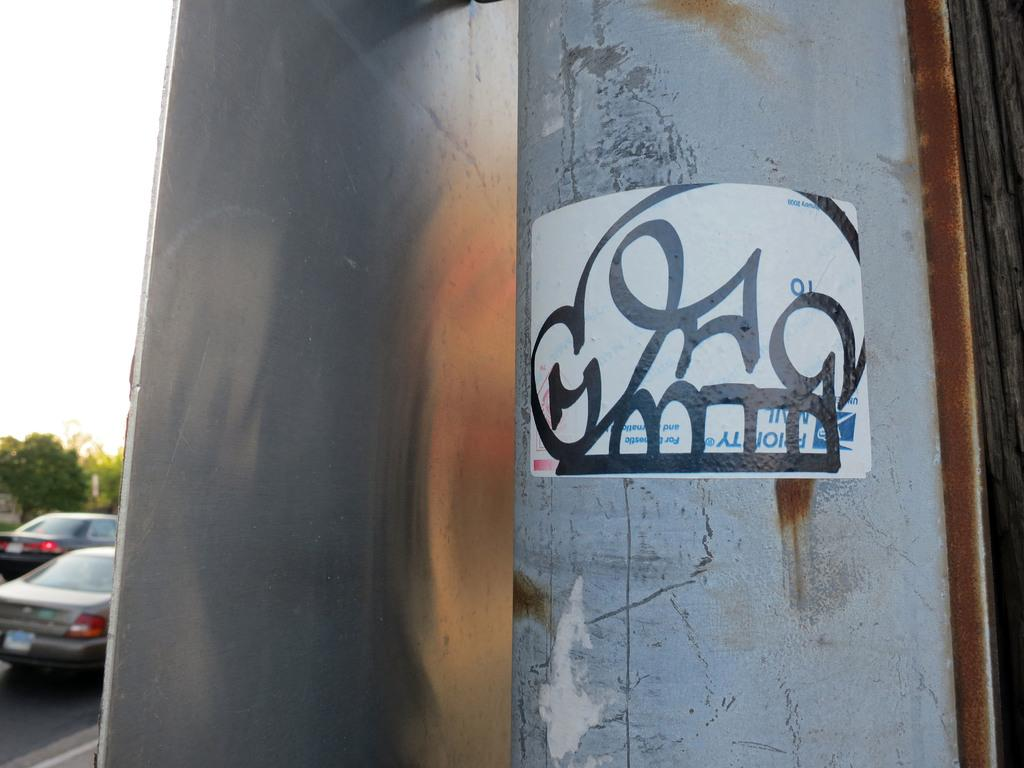What type of metal object is in the image? The fact does not specify the type of metal object, only that it is a metal object. What is on the left side of the image? There is a road on the left side of the image. What can be seen moving in the image? There are cars in the image, which are moving objects. What type of vegetation is in the image? There are trees in the image. What is visible in the background of the image? The sky is visible in the image. Where is the crib located in the image? There is no crib present in the image. What type of bag is being carried by the trees in the image? There are no bags associated with the trees in the image. 